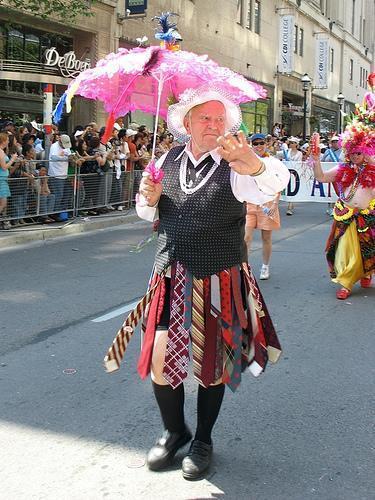How many people are there?
Give a very brief answer. 3. How many ties are there?
Give a very brief answer. 1. 